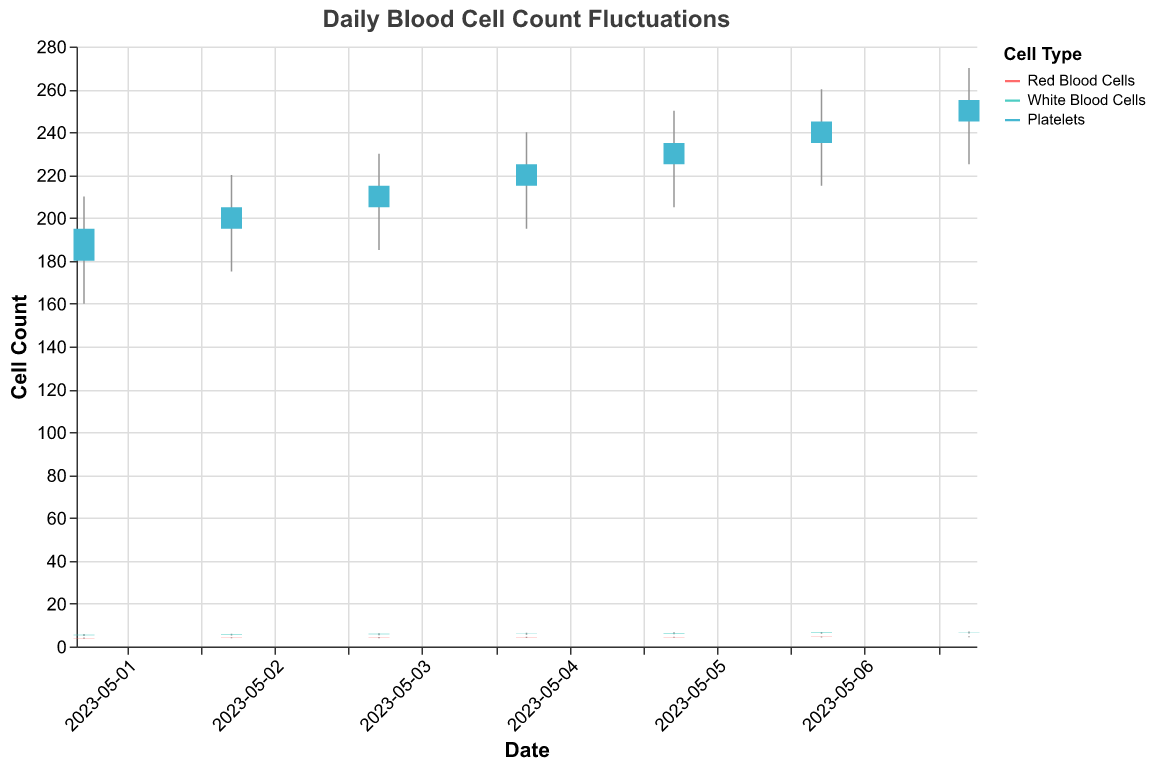What is the title of the chart? The title is usually displayed prominently at the top of the chart. In this case, it is "Daily Blood Cell Count Fluctuations".
Answer: Daily Blood Cell Count Fluctuations What does the y-axis represent? The y-axis typically represents the quantity being measured. Here, it is labeled "Cell Count", indicating it shows the count of different blood cells over time.
Answer: Cell Count Which cell type has the highest count on 2023-05-07? We need to compare the high values of the cell types on 2023-05-07. Red Blood Cells have a high of 4.8, White Blood Cells have a high of 7.0, and Platelets have a high of 270. The highest among these is 270 for Platelets.
Answer: Platelets What is the general trend of Red Blood Cells count over the week? Observe the opening and closing values of Red Blood Cells over the date range. The opening values start at 3.8 and increase to 4.5, and the closing values also increase from 4.0 to 4.6 over the week, suggesting an upward trend.
Answer: Increasing By how much did the White Blood Cells' count close increase from 2023-05-01 to 2023-05-07? Look at the closing values for White Blood Cells on these dates. The count on 2023-05-01 is 5.5, and on 2023-05-07 is 6.7. The increase is 6.7 - 5.5 = 1.2.
Answer: 1.2 Did Platelets ever fall below 175 in any day during the week? Review the low values for Platelets each day. The lowest value across all days is 160 on 2023-05-01, which is below 175.
Answer: Yes Which cell type varies the most in their high values throughout the week? We need to look at the range of high values for each cell type. Red Blood Cells high values range from 4.2 to 4.8, White Blood Cells from 5.8 to 7.0, and Platelets from 210 to 270. Platelets have the largest range of variation with (270 - 210) = 60.
Answer: Platelets What was the opening count of White Blood Cells on 2023-05-04? Check the relevant date and cell type for the opening count. For White Blood Cells on 2023-05-04, the opening count is 5.9.
Answer: 5.9 What is the median high value of Platelets during the week? List the high values: 210, 220, 230, 240, 250, 260, 270. The median is the middle value when they are ordered from least to greatest: the 4th value, which is 240.
Answer: 240 Which day saw the greatest increase in the opening count of Platelets? Calculate the daily increase by subtracting the previous day's opening count. The greatest increase occurs between 2023-05-06 (235) and 2023-05-07 (245), a difference of 10.
Answer: 2023-05-07 